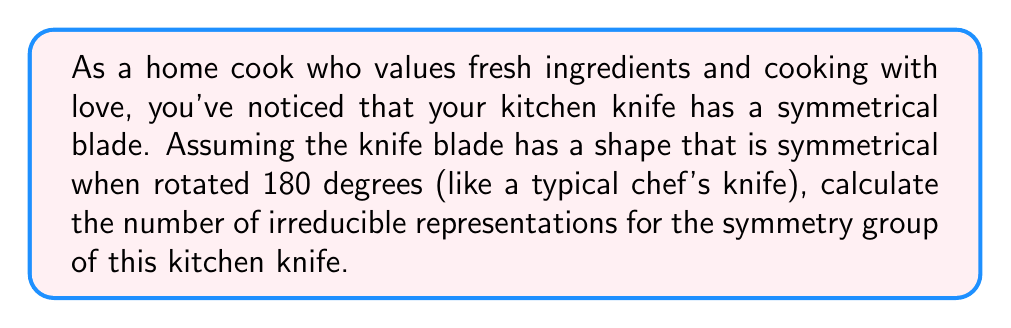Help me with this question. Let's approach this step-by-step:

1) The symmetry group of a typical kitchen knife blade is $C_{2}$, which has two elements:
   - The identity operation (no rotation)
   - A 180-degree rotation

2) For finite groups, the number of irreducible representations is equal to the number of conjugacy classes in the group.

3) In $C_{2}$, each element forms its own conjugacy class:
   - $\{e\}$ (identity)
   - $\{r\}$ (180-degree rotation)

4) Therefore, there are two conjugacy classes in $C_{2}$.

5) The character table for $C_{2}$ is:

   $$
   \begin{array}{c|cc}
   C_{2} & e & r \\
   \hline
   \chi_{1} & 1 & 1 \\
   \chi_{2} & 1 & -1
   \end{array}
   $$

   This table shows two irreducible representations: $\chi_{1}$ and $\chi_{2}$.

6) The irreducible representations correspond to:
   - The trivial representation ($\chi_{1}$)
   - The sign representation ($\chi_{2}$)

Thus, the symmetry group of the kitchen knife has two irreducible representations.
Answer: 2 